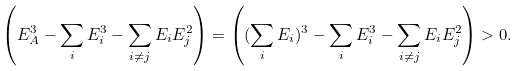Convert formula to latex. <formula><loc_0><loc_0><loc_500><loc_500>\left ( E _ { A } ^ { 3 } - \sum _ { i } E _ { i } ^ { 3 } - \sum _ { i \neq j } E _ { i } E _ { j } ^ { 2 } \right ) = \left ( ( \sum _ { i } E _ { i } ) ^ { 3 } - \sum _ { i } E _ { i } ^ { 3 } - \sum _ { i \neq j } E _ { i } E _ { j } ^ { 2 } \right ) > 0 .</formula> 